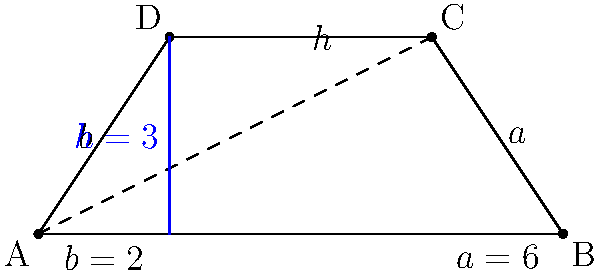In the trapezoid ABCD shown above, the parallel sides have lengths $a=6$ and $b=2$, and the height $h=3$. Calculate the area of the trapezoid. To find the area of a trapezoid, we can use the formula:

$$A = \frac{1}{2}(a+b)h$$

Where:
- $A$ is the area of the trapezoid
- $a$ and $b$ are the lengths of the parallel sides
- $h$ is the height of the trapezoid

Given:
- $a = 6$
- $b = 2$
- $h = 3$

Let's substitute these values into the formula:

$$\begin{align*}
A &= \frac{1}{2}(a+b)h \\
&= \frac{1}{2}(6+2)3 \\
&= \frac{1}{2}(8)3 \\
&= 4 \times 3 \\
&= 12
\end{align*}$$

Therefore, the area of the trapezoid is 12 square units.
Answer: 12 square units 